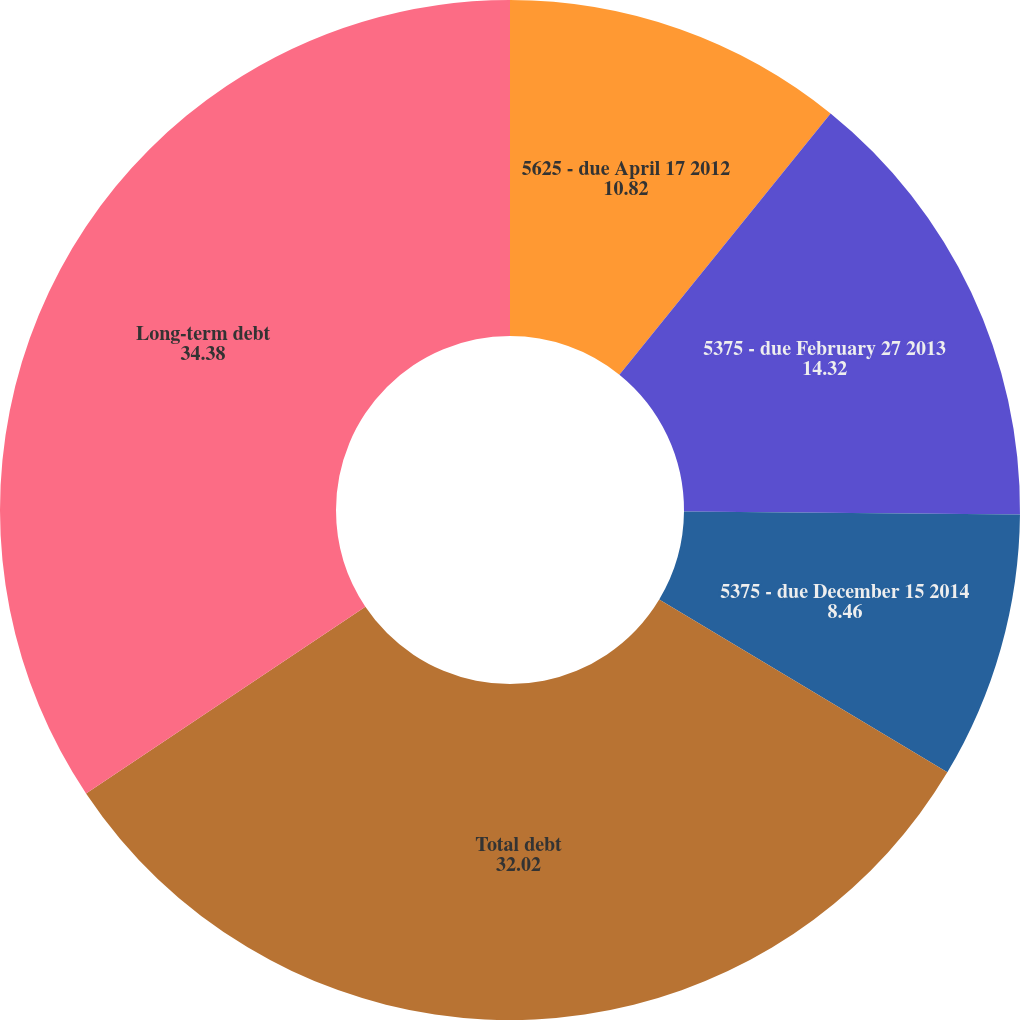<chart> <loc_0><loc_0><loc_500><loc_500><pie_chart><fcel>5625 - due April 17 2012<fcel>5375 - due February 27 2013<fcel>5375 - due December 15 2014<fcel>Total debt<fcel>Long-term debt<nl><fcel>10.82%<fcel>14.32%<fcel>8.46%<fcel>32.02%<fcel>34.38%<nl></chart> 